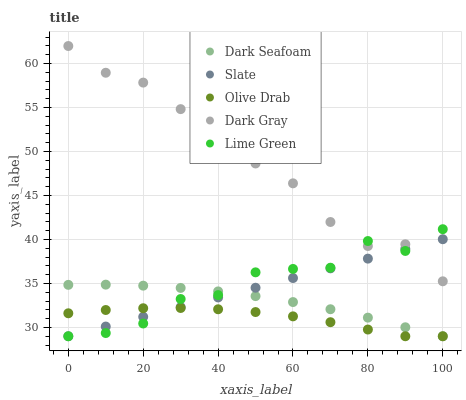Does Olive Drab have the minimum area under the curve?
Answer yes or no. Yes. Does Dark Gray have the maximum area under the curve?
Answer yes or no. Yes. Does Dark Seafoam have the minimum area under the curve?
Answer yes or no. No. Does Dark Seafoam have the maximum area under the curve?
Answer yes or no. No. Is Slate the smoothest?
Answer yes or no. Yes. Is Dark Gray the roughest?
Answer yes or no. Yes. Is Dark Seafoam the smoothest?
Answer yes or no. No. Is Dark Seafoam the roughest?
Answer yes or no. No. Does Dark Seafoam have the lowest value?
Answer yes or no. Yes. Does Dark Gray have the highest value?
Answer yes or no. Yes. Does Dark Seafoam have the highest value?
Answer yes or no. No. Is Olive Drab less than Dark Gray?
Answer yes or no. Yes. Is Dark Gray greater than Dark Seafoam?
Answer yes or no. Yes. Does Olive Drab intersect Lime Green?
Answer yes or no. Yes. Is Olive Drab less than Lime Green?
Answer yes or no. No. Is Olive Drab greater than Lime Green?
Answer yes or no. No. Does Olive Drab intersect Dark Gray?
Answer yes or no. No. 